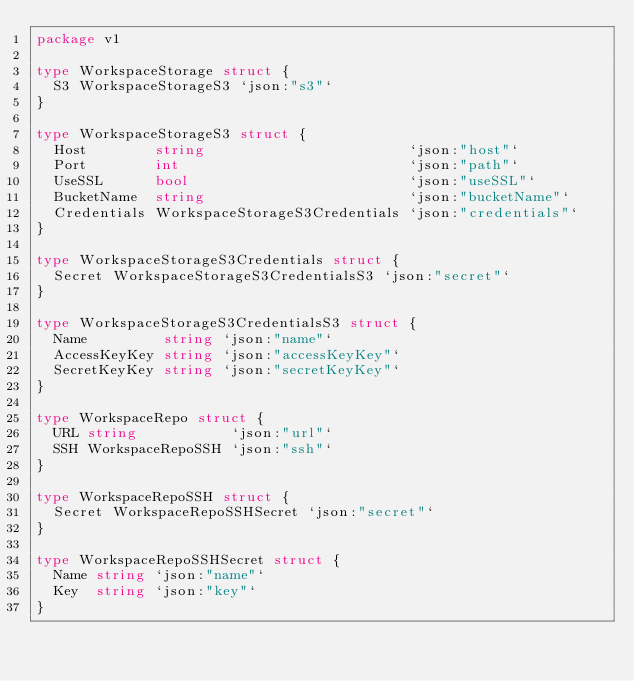<code> <loc_0><loc_0><loc_500><loc_500><_Go_>package v1

type WorkspaceStorage struct {
	S3 WorkspaceStorageS3 `json:"s3"`
}

type WorkspaceStorageS3 struct {
	Host        string                        `json:"host"`
	Port        int                           `json:"path"`
	UseSSL      bool                          `json:"useSSL"`
	BucketName  string                        `json:"bucketName"`
	Credentials WorkspaceStorageS3Credentials `json:"credentials"`
}

type WorkspaceStorageS3Credentials struct {
	Secret WorkspaceStorageS3CredentialsS3 `json:"secret"`
}

type WorkspaceStorageS3CredentialsS3 struct {
	Name         string `json:"name"`
	AccessKeyKey string `json:"accessKeyKey"`
	SecretKeyKey string `json:"secretKeyKey"`
}

type WorkspaceRepo struct {
	URL string           `json:"url"`
	SSH WorkspaceRepoSSH `json:"ssh"`
}

type WorkspaceRepoSSH struct {
	Secret WorkspaceRepoSSHSecret `json:"secret"`
}

type WorkspaceRepoSSHSecret struct {
	Name string `json:"name"`
	Key  string `json:"key"`
}
</code> 